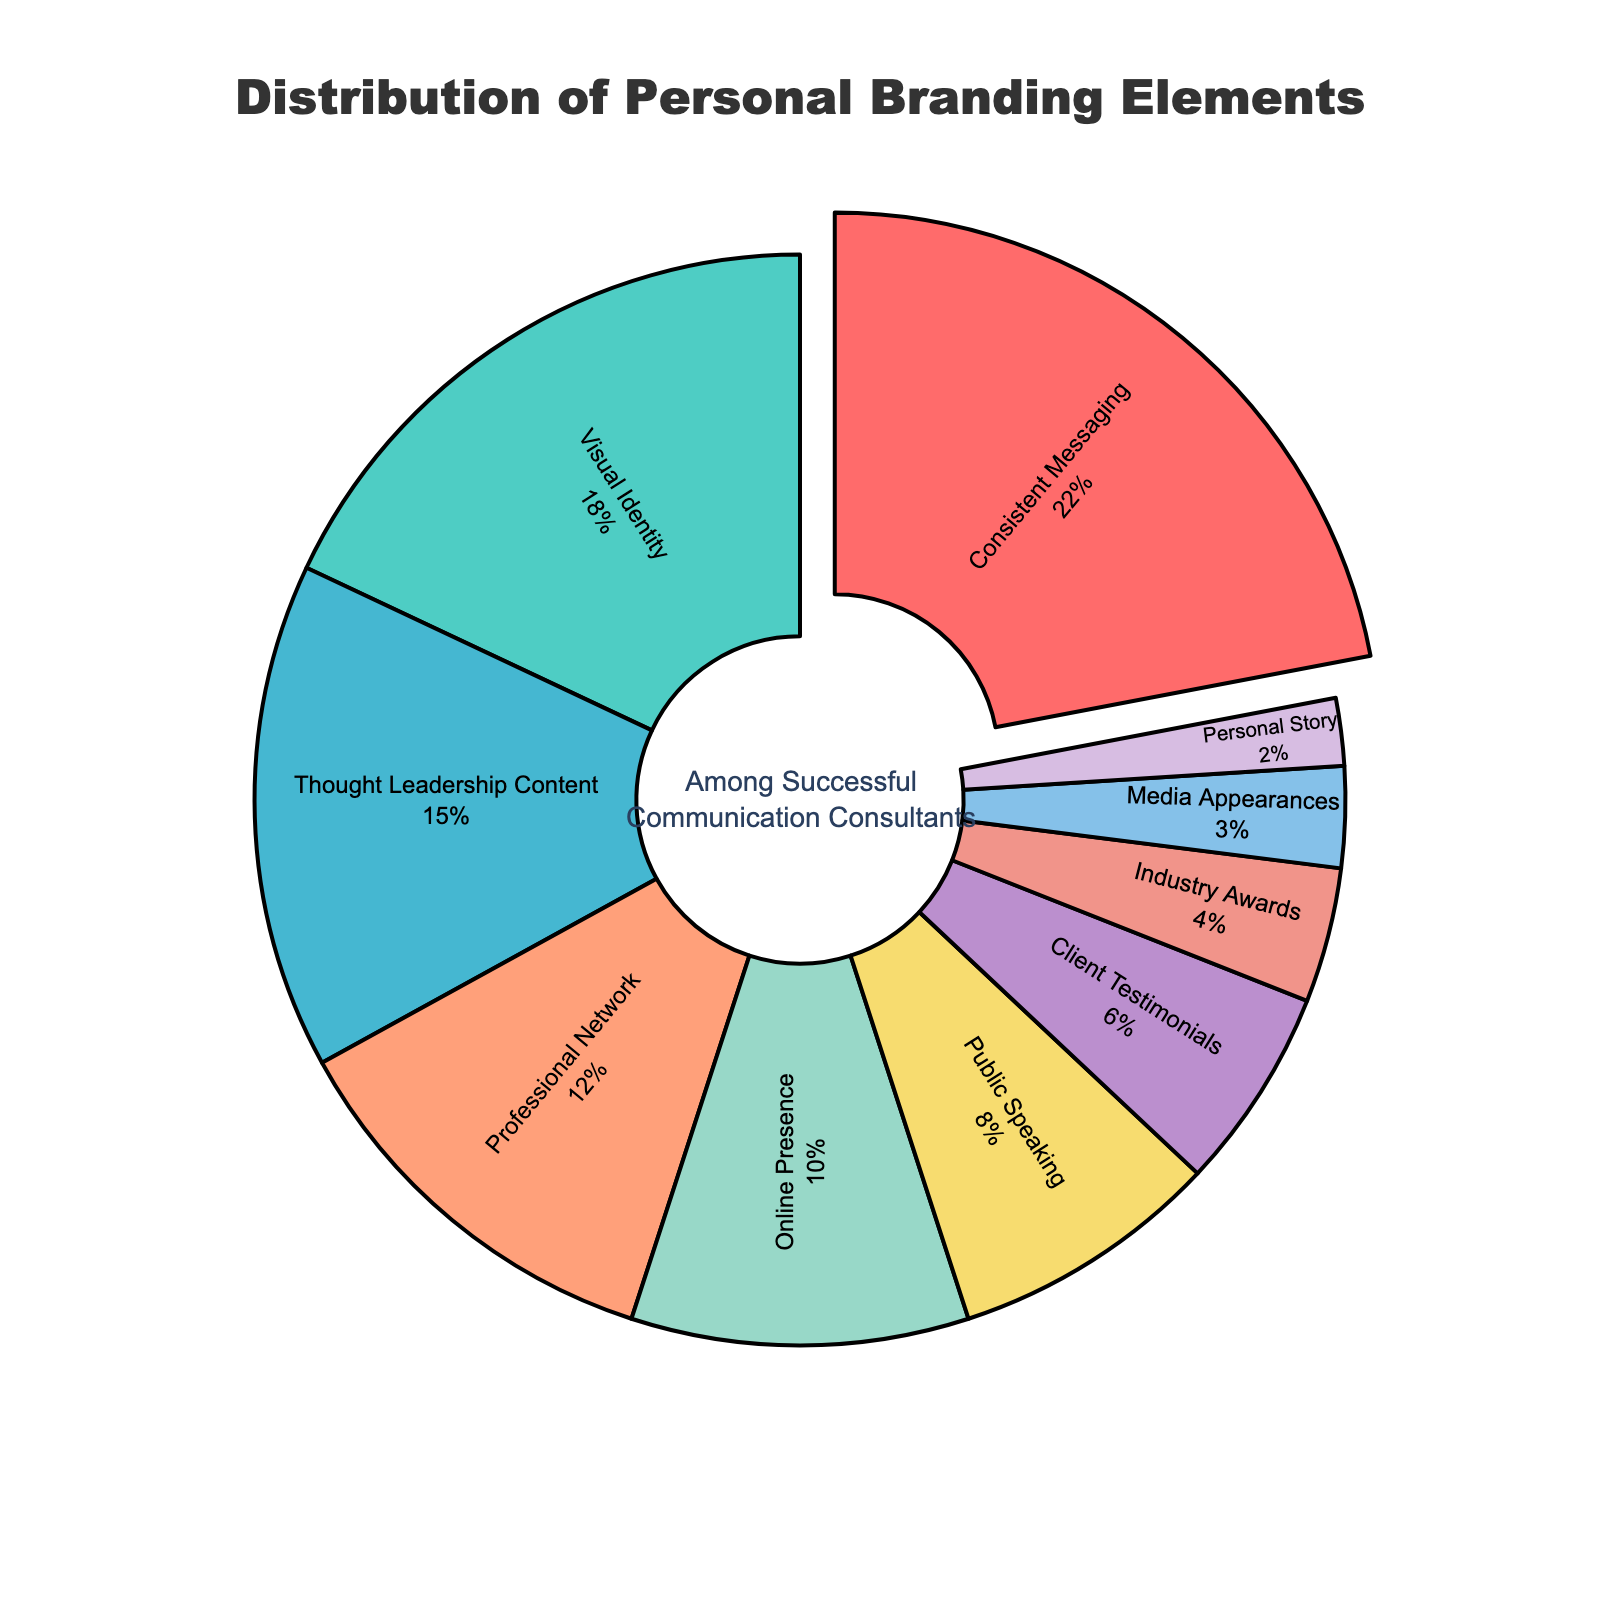What's the most prominent element in the distribution? The element with the largest slice in the pie chart is "Consistent Messaging" which is visually distinct and slightly pulled out. It also has the highest percentage label of 22%
Answer: Consistent Messaging Which elements account for less than 10% each? Looking at the pie chart, the elements that are visually smaller and have percentage labels below 10% are "Online Presence" (10%), "Public Speaking" (8%), "Client Testimonials" (6%), "Industry Awards" (4%), "Media Appearances" (3%), and "Personal Story" (2%)
Answer: Online Presence, Public Speaking, Client Testimonials, Industry Awards, Media Appearances, Personal Story If you combine the percentages of "Thought Leadership Content" and "Professional Network," how much of the distribution do they collectively represent? The percentage for "Thought Leadership Content" is 15%, and for "Professional Network" it is 12%. Adding them together: 15% + 12% = 27%
Answer: 27% How does the percentage of "Visual Identity" compare to "Consistent Messaging"? The percentage of "Visual Identity" is 18%, while "Consistent Messaging" is 22%. Thus, "Consistent Messaging" has a higher percentage than "Visual Identity" by 4%
Answer: Consistent Messaging is higher by 4% Which element has the least representation and what is its percentage? The smallest slice in the pie chart, both visually and numerically, is "Personal Story" with a percentage label of 2%
Answer: Personal Story, 2% What percentage of the distribution is accounted for by "Public Speaking" and "Client Testimonials" combined? The percentage for "Public Speaking" is 8%, and for "Client Testimonials" it is 6%. Adding them together: 8% + 6% = 14%
Answer: 14% What's the combined percentage of the three smallest elements? The three smallest percentages are for "Media Appearances" (3%), "Industry Awards" (4%), and "Personal Story" (2%). Adding them together: 3% + 4% + 2% = 9%
Answer: 9% Rank the top three elements from highest to lowest based on their share in the distribution. The top three elements in the pie chart by percentage are "Consistent Messaging" (22%), followed by "Visual Identity" (18%), and then "Thought Leadership Content" (15%)
Answer: Consistent Messaging, Visual Identity, Thought Leadership Content 